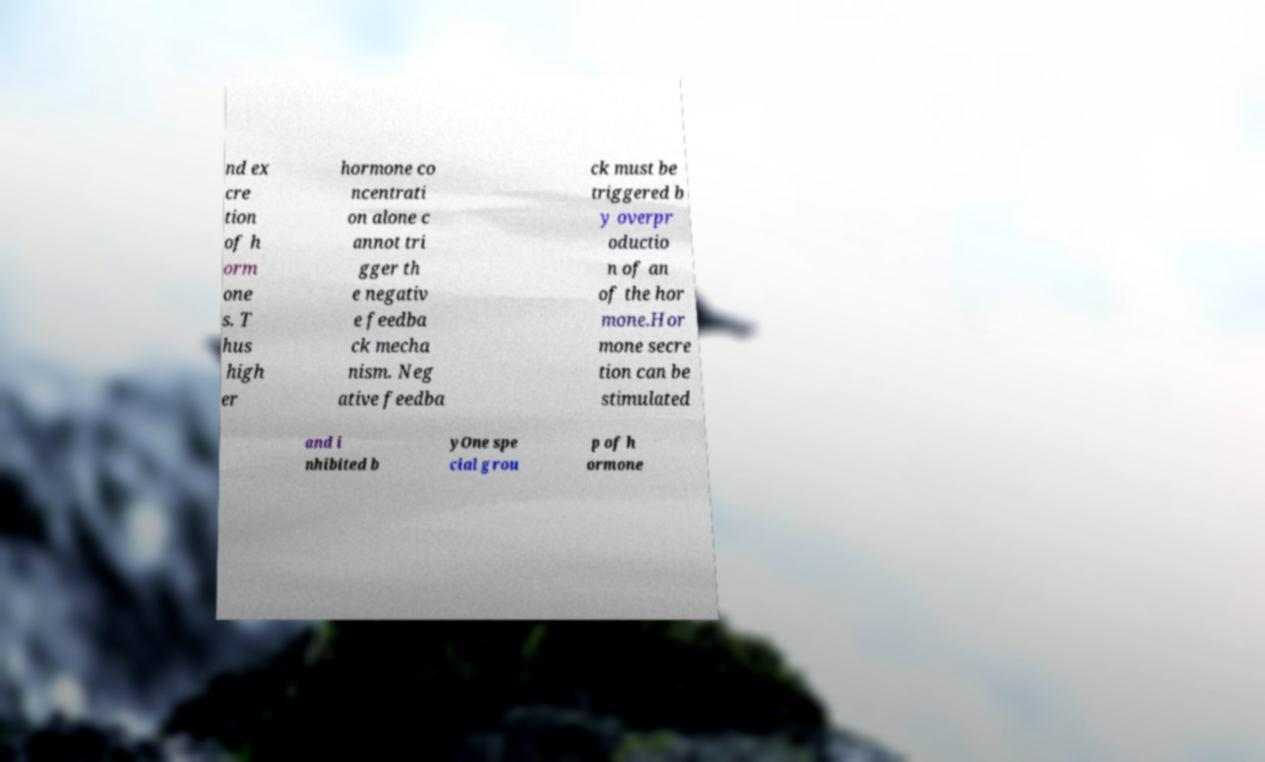What messages or text are displayed in this image? I need them in a readable, typed format. nd ex cre tion of h orm one s. T hus high er hormone co ncentrati on alone c annot tri gger th e negativ e feedba ck mecha nism. Neg ative feedba ck must be triggered b y overpr oductio n of an of the hor mone.Hor mone secre tion can be stimulated and i nhibited b yOne spe cial grou p of h ormone 